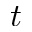<formula> <loc_0><loc_0><loc_500><loc_500>t</formula> 